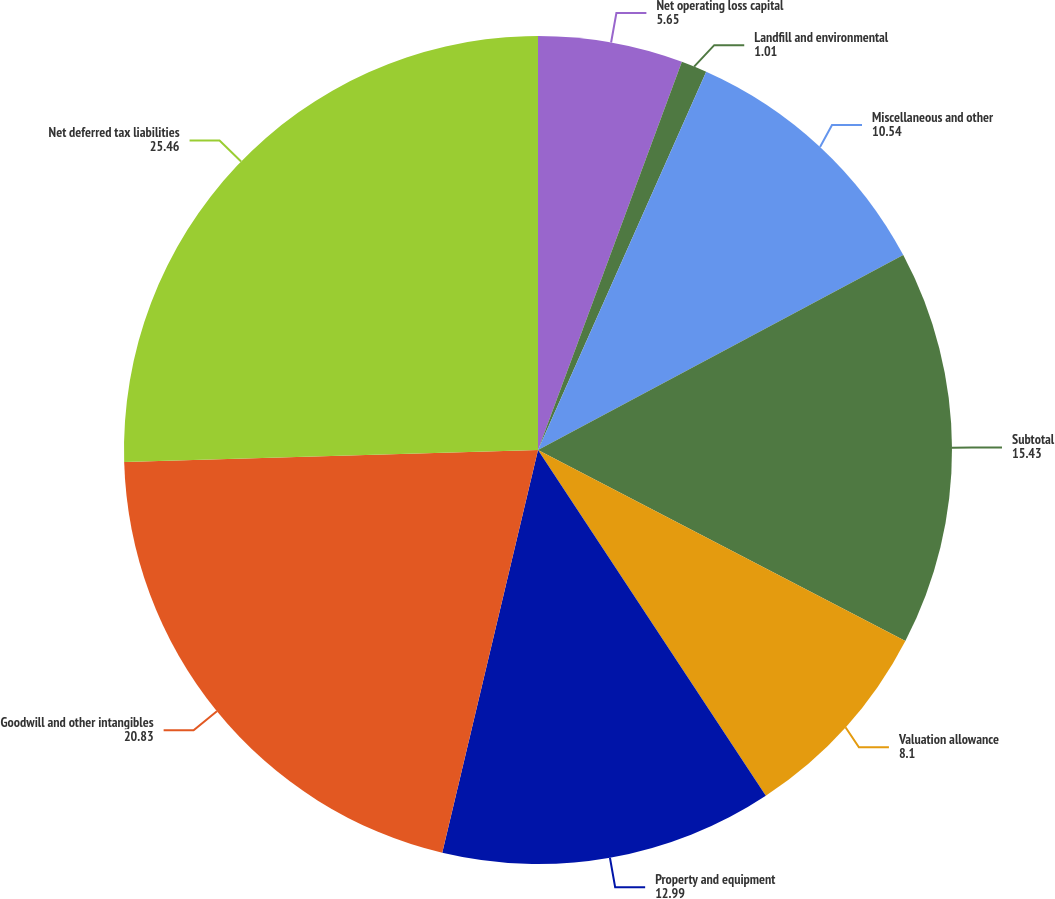Convert chart to OTSL. <chart><loc_0><loc_0><loc_500><loc_500><pie_chart><fcel>Net operating loss capital<fcel>Landfill and environmental<fcel>Miscellaneous and other<fcel>Subtotal<fcel>Valuation allowance<fcel>Property and equipment<fcel>Goodwill and other intangibles<fcel>Net deferred tax liabilities<nl><fcel>5.65%<fcel>1.01%<fcel>10.54%<fcel>15.43%<fcel>8.1%<fcel>12.99%<fcel>20.83%<fcel>25.46%<nl></chart> 